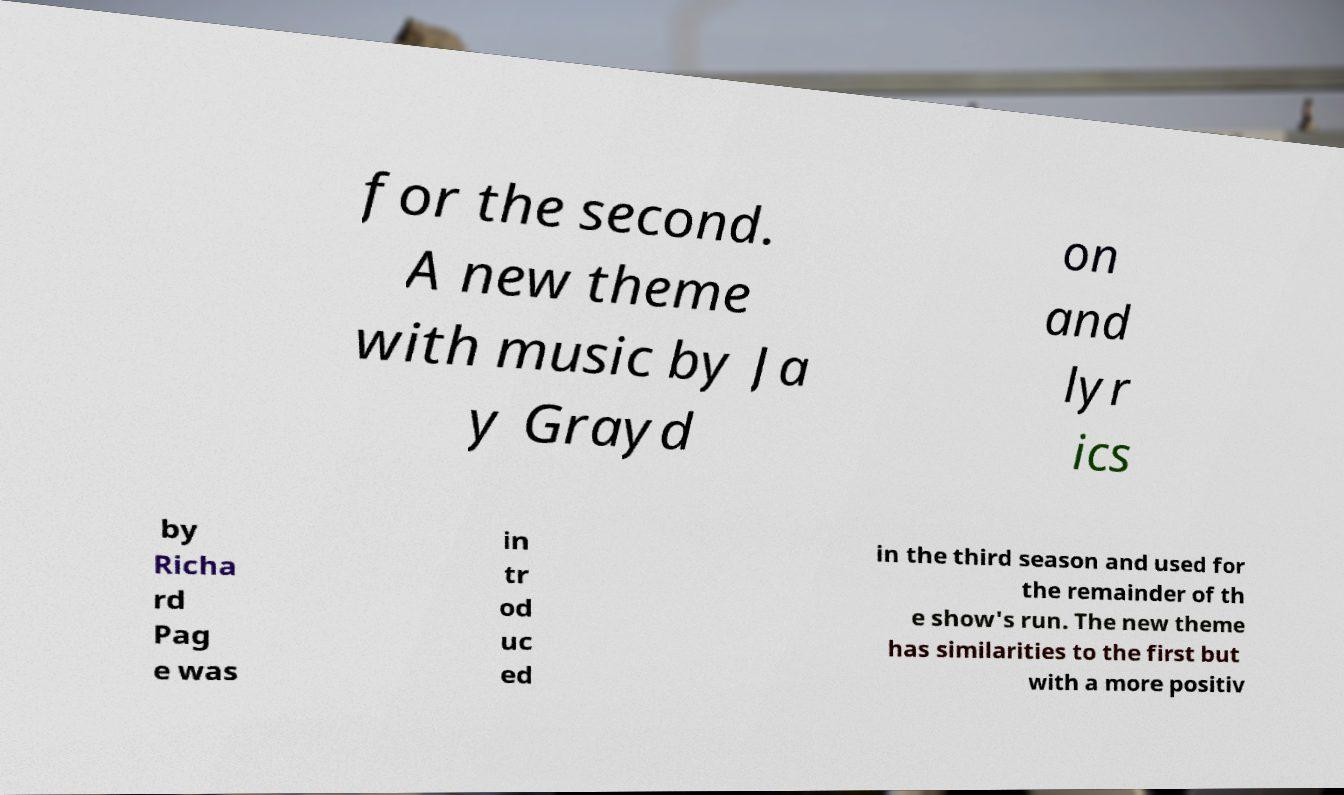Can you accurately transcribe the text from the provided image for me? for the second. A new theme with music by Ja y Grayd on and lyr ics by Richa rd Pag e was in tr od uc ed in the third season and used for the remainder of th e show's run. The new theme has similarities to the first but with a more positiv 